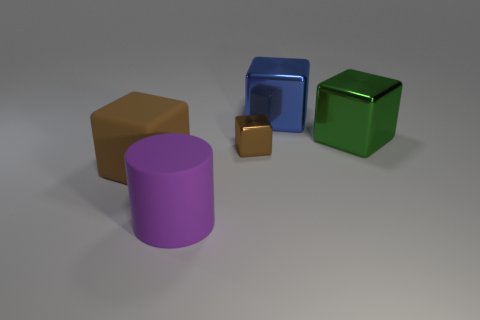What size is the metallic block that is the same color as the rubber cube?
Offer a terse response. Small. What number of tiny brown metallic objects have the same shape as the large brown thing?
Your answer should be very brief. 1. Is the size of the green block the same as the brown object that is on the left side of the purple cylinder?
Keep it short and to the point. Yes. What number of other things are there of the same color as the tiny thing?
Make the answer very short. 1. There is a blue metal block; are there any small brown blocks on the left side of it?
Your response must be concise. Yes. What number of things are matte objects or big cubes to the left of the blue object?
Your answer should be very brief. 2. Is there a shiny block in front of the thing that is behind the large green thing?
Your response must be concise. Yes. What shape is the matte object that is left of the thing in front of the big cube that is on the left side of the small thing?
Offer a terse response. Cube. What color is the block that is in front of the large green cube and right of the large purple rubber cylinder?
Your answer should be very brief. Brown. There is a brown thing to the right of the brown matte thing; what shape is it?
Your answer should be compact. Cube. 